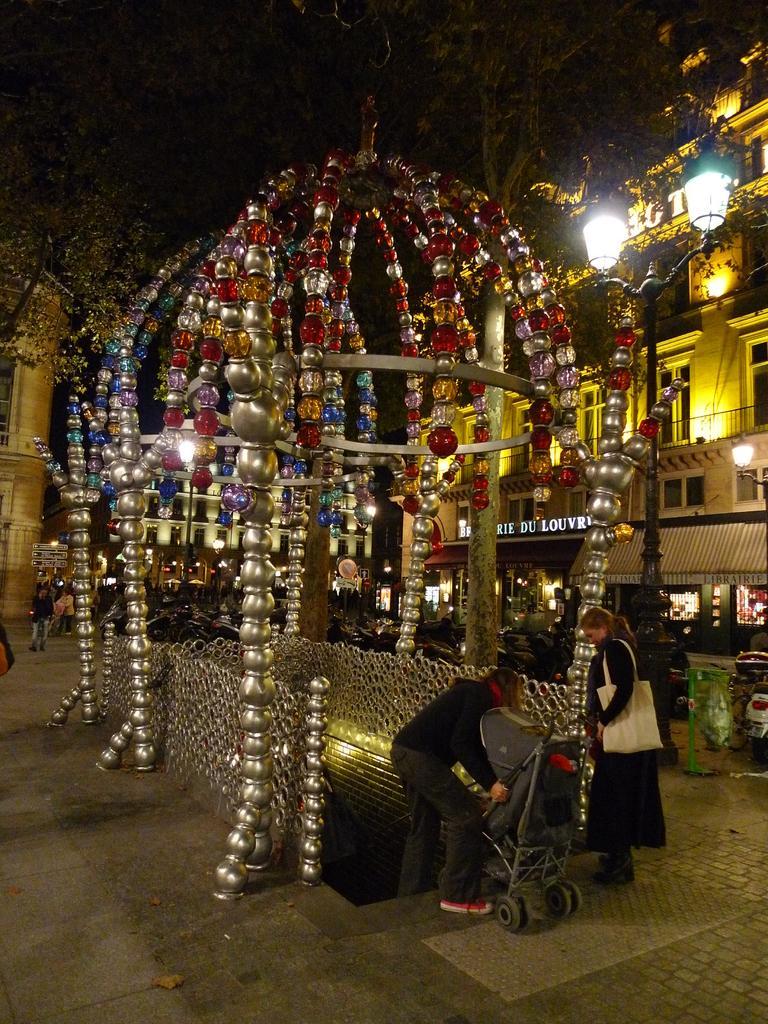How would you summarize this image in a sentence or two? In this picture we can see the buildings, lights, poles, decor, board, stores, vehicles, trolley and some people. At the bottom of the image we can see the road. At the top of the image we can see the sky and trees. 